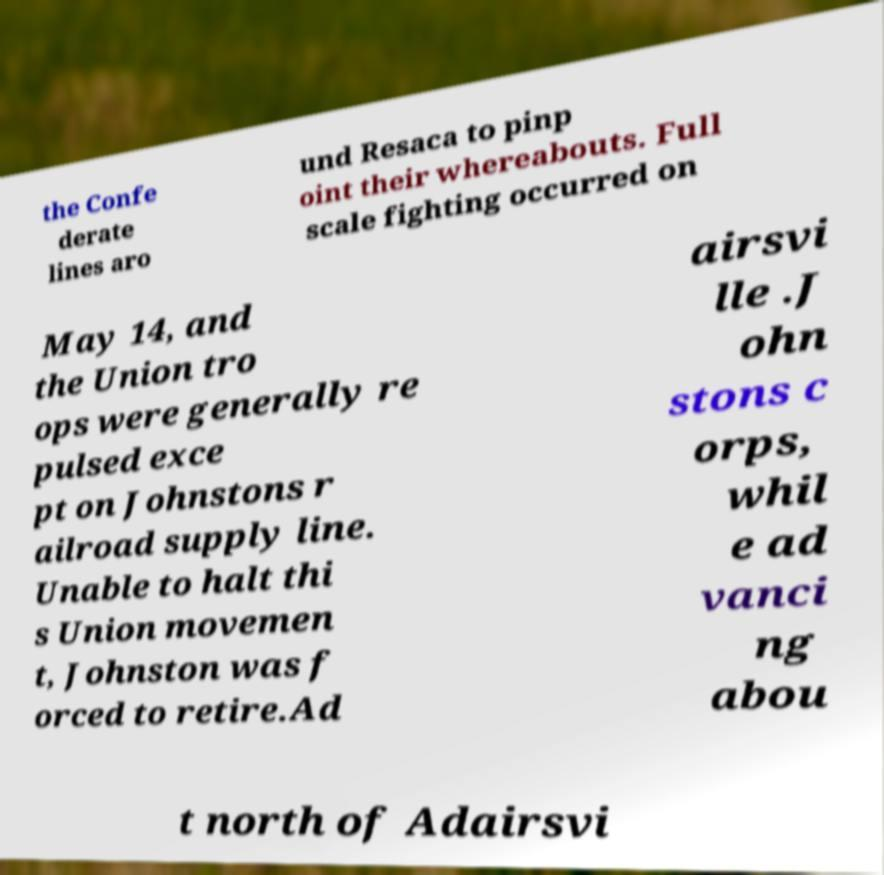There's text embedded in this image that I need extracted. Can you transcribe it verbatim? the Confe derate lines aro und Resaca to pinp oint their whereabouts. Full scale fighting occurred on May 14, and the Union tro ops were generally re pulsed exce pt on Johnstons r ailroad supply line. Unable to halt thi s Union movemen t, Johnston was f orced to retire.Ad airsvi lle .J ohn stons c orps, whil e ad vanci ng abou t north of Adairsvi 